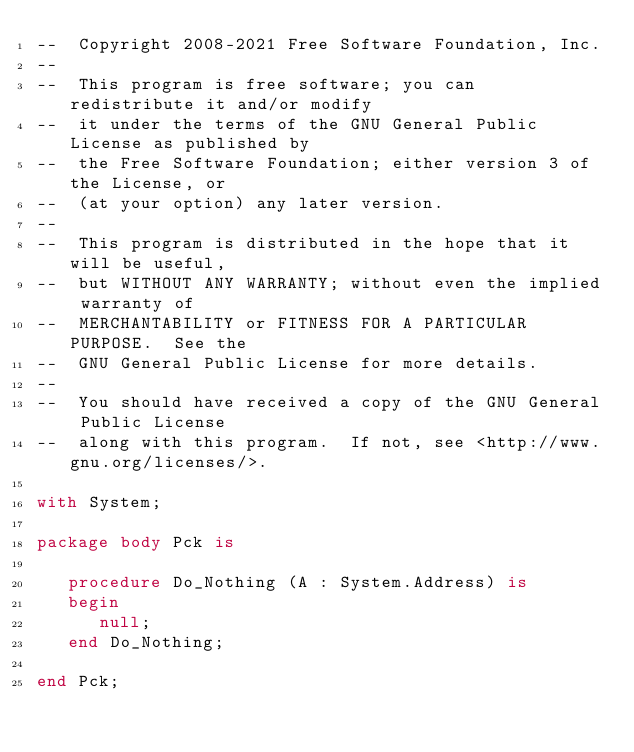<code> <loc_0><loc_0><loc_500><loc_500><_Ada_>--  Copyright 2008-2021 Free Software Foundation, Inc.
--
--  This program is free software; you can redistribute it and/or modify
--  it under the terms of the GNU General Public License as published by
--  the Free Software Foundation; either version 3 of the License, or
--  (at your option) any later version.
--
--  This program is distributed in the hope that it will be useful,
--  but WITHOUT ANY WARRANTY; without even the implied warranty of
--  MERCHANTABILITY or FITNESS FOR A PARTICULAR PURPOSE.  See the
--  GNU General Public License for more details.
--
--  You should have received a copy of the GNU General Public License
--  along with this program.  If not, see <http://www.gnu.org/licenses/>.

with System;

package body Pck is

   procedure Do_Nothing (A : System.Address) is
   begin
      null;
   end Do_Nothing;

end Pck;
</code> 